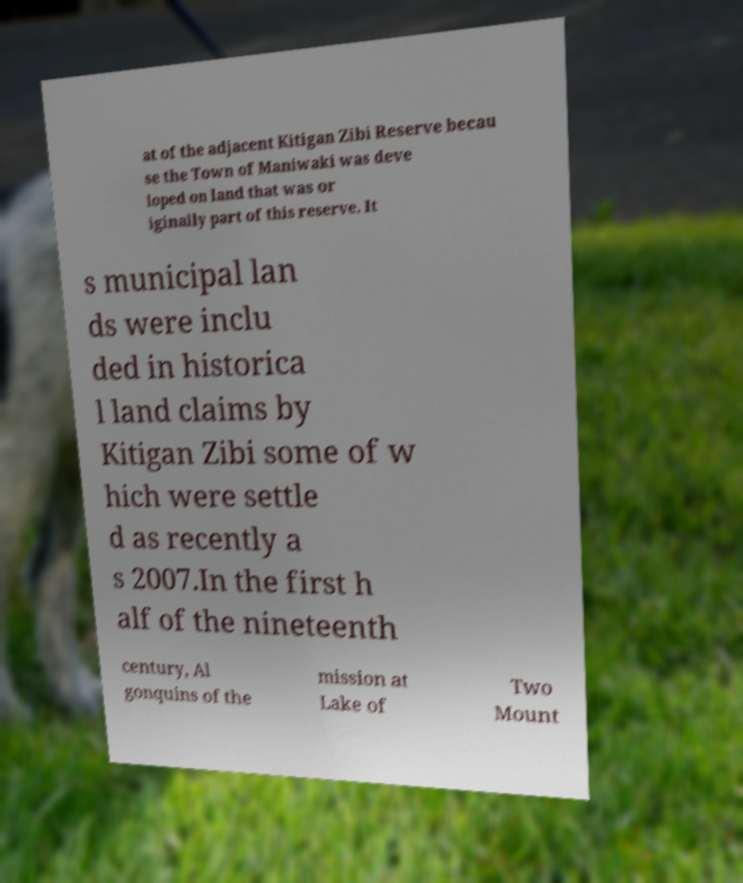Please read and relay the text visible in this image. What does it say? at of the adjacent Kitigan Zibi Reserve becau se the Town of Maniwaki was deve loped on land that was or iginally part of this reserve. It s municipal lan ds were inclu ded in historica l land claims by Kitigan Zibi some of w hich were settle d as recently a s 2007.In the first h alf of the nineteenth century, Al gonquins of the mission at Lake of Two Mount 